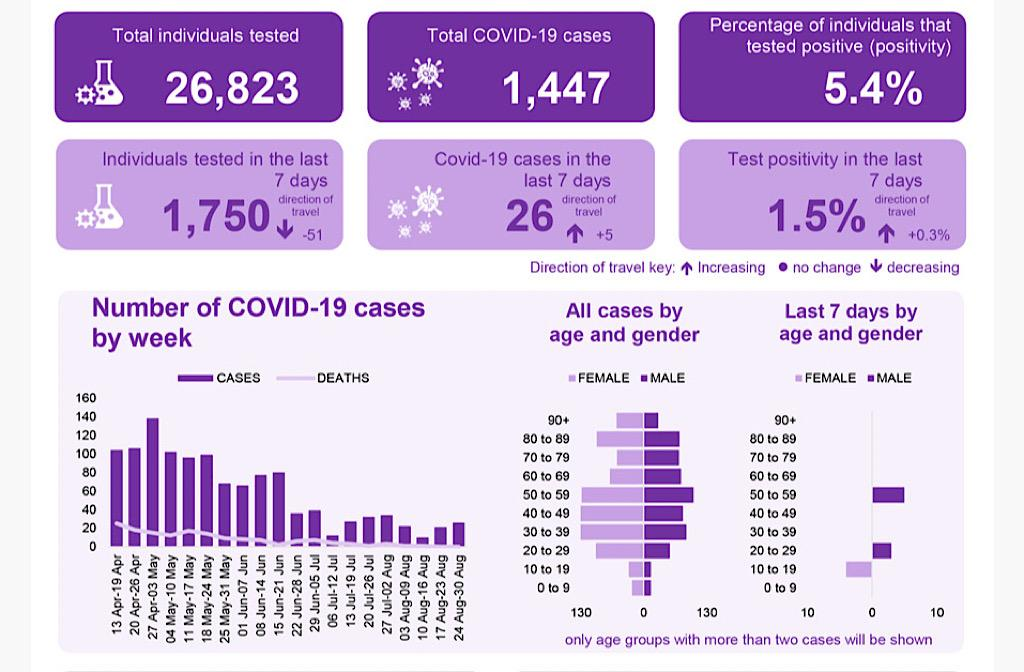Draw attention to some important aspects in this diagram. In terms of overall incidence, the age group with the highest number of COVID-19 cases among males is those between 50 and 59 years old. The number of COVID-19 cases in the last seven days has increased by 5. The test positivity rate in the previous 7 days was 1.5%. Out of the total individuals tested, 1,447 were positive for Covid-19. During the week of April 13th to April 19th, the number of COVID-19 deaths reached its highest point. 